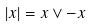<formula> <loc_0><loc_0><loc_500><loc_500>| x | = x \vee - x</formula> 